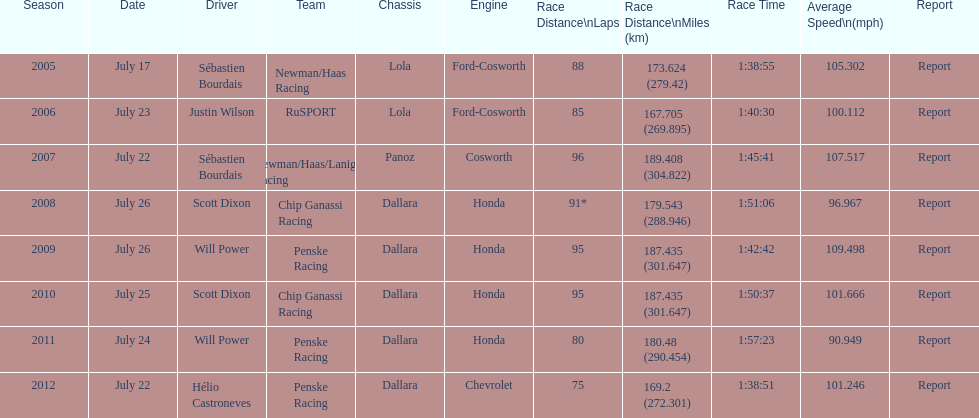What is the cumulative count of honda engines? 4. 